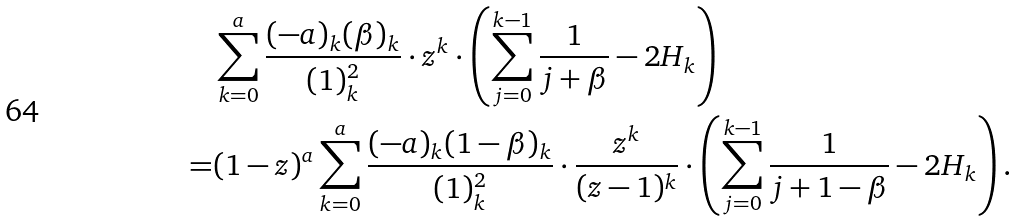<formula> <loc_0><loc_0><loc_500><loc_500>& \sum _ { k = 0 } ^ { a } \frac { ( - a ) _ { k } ( \beta ) _ { k } } { ( 1 ) _ { k } ^ { 2 } } \cdot z ^ { k } \cdot \left ( \sum _ { j = 0 } ^ { k - 1 } \frac { 1 } { j + \beta } - 2 H _ { k } \right ) \\ = & ( 1 - z ) ^ { a } \sum _ { k = 0 } ^ { a } \frac { ( - a ) _ { k } ( 1 - \beta ) _ { k } } { ( 1 ) _ { k } ^ { 2 } } \cdot \frac { z ^ { k } } { ( z - 1 ) ^ { k } } \cdot \left ( \sum _ { j = 0 } ^ { k - 1 } \frac { 1 } { j + 1 - \beta } - 2 H _ { k } \right ) .</formula> 